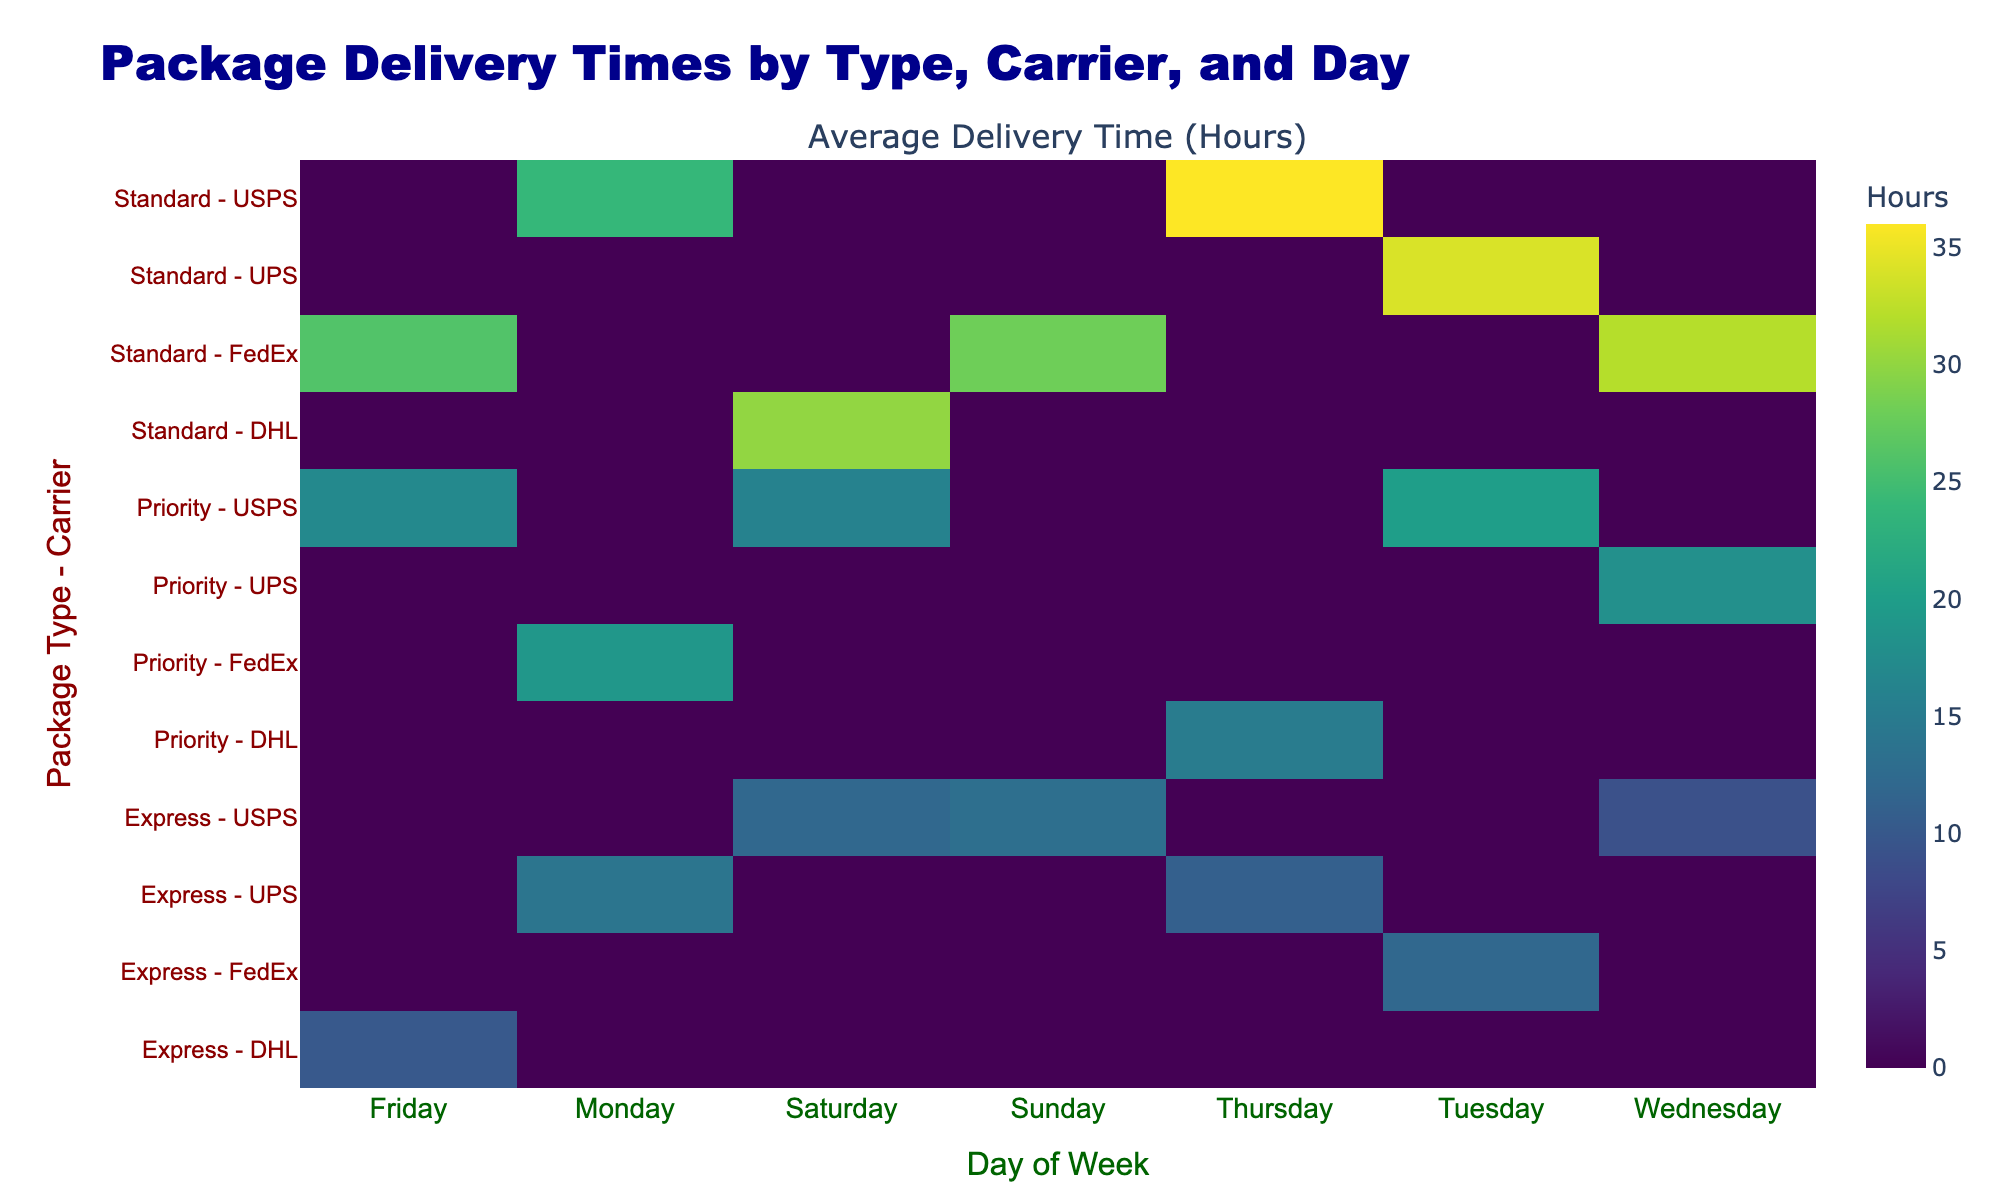What is the average delivery time for Express packages on Mondays? For Express packages on Mondays, we have data from two carriers: USPS (14 hours) and UPS (11 hours). To find the average, we sum the delivery times: 14 + 11 = 25. Then, we divide by the number of entries (2): 25 / 2 = 12.5 hours.
Answer: 12.5 hours Which carrier has the longest average delivery time for Standard packages? Looking at the Standard packages, we have two carriers: USPS with an average delivery time of 30 + 36 + 34 = 100 hours (3 data points) which averages to 100 / 3 = 33.3 hours, and FedEx with 32 hours. Comparing these, the longest average is from USPS at 33.3 hours.
Answer: USPS Is the delivery time for Priority packages on Tuesday higher than for Standard packages on Thursday? On Tuesday, the average delivery time for Priority packages is 16 hours (from USPS), and for Standard packages on Thursday, it is 36 hours (from USPS) as well. Since 36 is greater than 16, the answer is yes.
Answer: Yes What is the total delivery time for Express packages across all weekdays? We break down the delivery times for Express packages: Monday (14 hours by UPS) + Tuesday (12 hours by USPS) + Wednesday (9 hours by USPS) + Thursday (11 hours by UPS) + Friday (10 hours by DHL) + Saturday (13 hours by USPS) + Sunday (4.5 hours by USPS). The total is 14 + 12 + 9 + 11 + 10 + 13 + 4.5 = 79.5 hours.
Answer: 79.5 hours Which package type has the highest delivery time on Friday, and what is that time? Checking the delivery times on Friday: Express is 10 (DHL), Standard is 32 (FedEx), and Priority is 17 (USPS). The highest delivery time is from Standard packages with 32 hours from FedEx.
Answer: Standard packages with 32 hours On which day does FedEx have the lowest average delivery time for packages? Looking at FedEx, their delivery times by day for all package types are: Tuesday (12 hours, Express), Friday (32 hours, Standard), and Monday (19 hours, Priority). The lowest is 12 hours on Tuesday.
Answer: Tuesday with 12 hours Did USPS have any delivery times over 30 hours for Standard packages? Analyzing the Standard packages, USPS had delivery times of 30 (Saturday), 36 (Thursday), and 34 (Tuesday). All times are above 30 hours, confirming that they did have delivery times over 30 hours.
Answer: Yes What is the difference between the average delivery time for Priority packages on Wednesday and Express packages on Friday? For Priority packages on Wednesday, the delivery time is 18 hours, while for Express packages on Friday, it's 10 hours. The difference is 18 - 10 = 8 hours.
Answer: 8 hours Which carrier has the highest average customer rating, and what is that rating? By checking the customer ratings per carrier, we see: USPS has 4.2 + 4.3 + 4.1 + 4.4 + 4.8 + 3.9 = 25.7 (average of 4.29), FedEx has 4.8 + 4.0 + 4.2 + 3.8 = 16.8 (average of 4.2), DHL has 4.7 + 4.3 = 9 (average of 4.45), UPS has 4.5 + 4.6 = 9.1 (average of 4.55). The carrier with the highest average is UPS with 4.55.
Answer: UPS with 4.55 